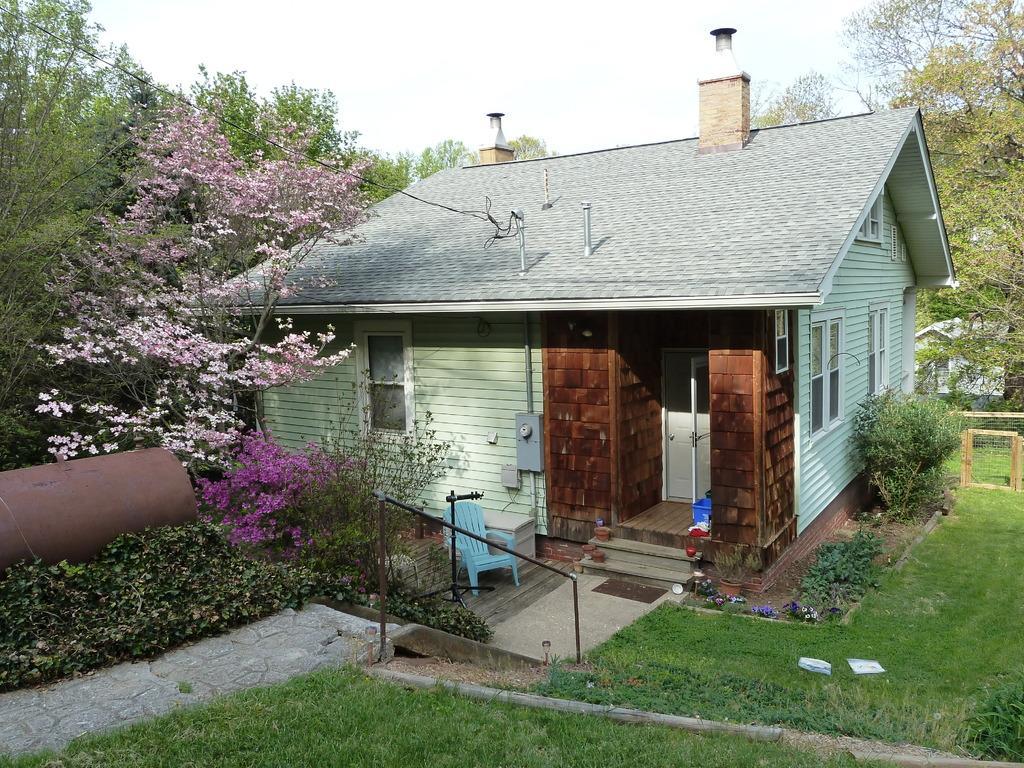Can you describe this image briefly? In this picture I can see the grass in front and I can see few plants and trees. I can also see few flowers, which are of pink color. In the middle of this picture I can see a house and I can see a chair. In the background I can see the sky. 